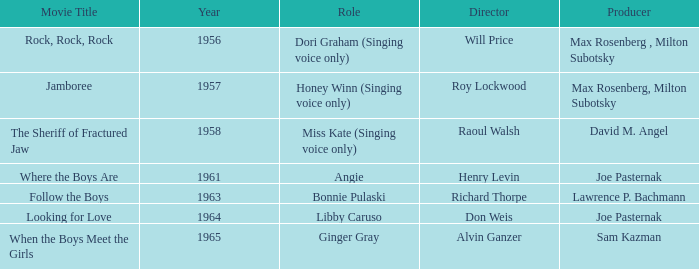What were the functions in 1961? Angie. 